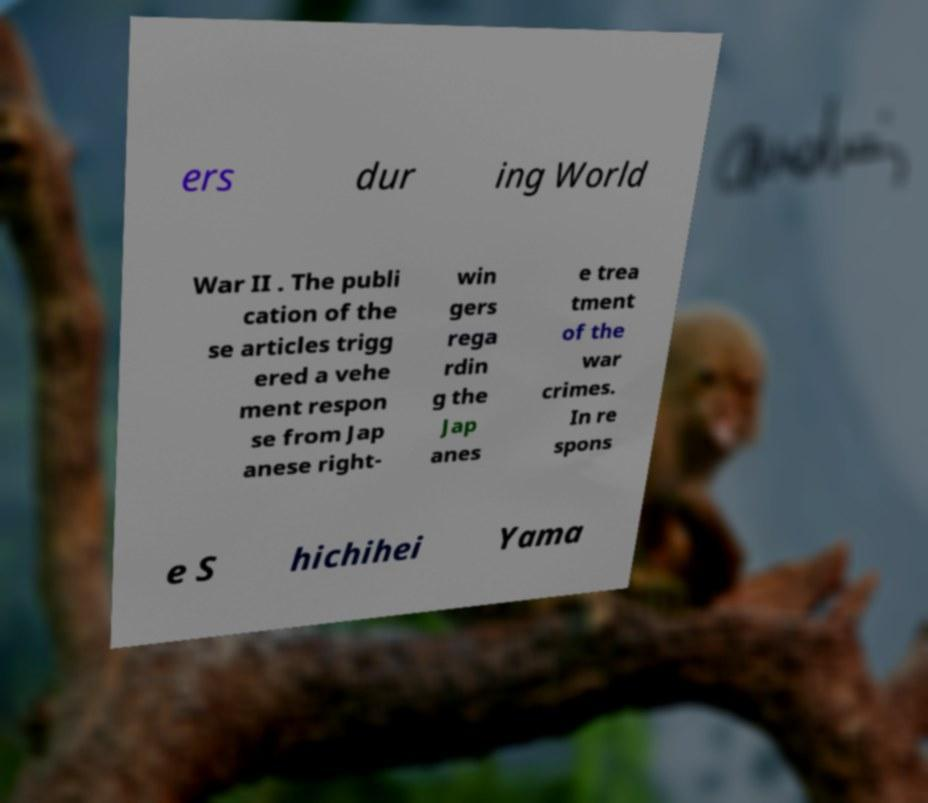I need the written content from this picture converted into text. Can you do that? ers dur ing World War II . The publi cation of the se articles trigg ered a vehe ment respon se from Jap anese right- win gers rega rdin g the Jap anes e trea tment of the war crimes. In re spons e S hichihei Yama 